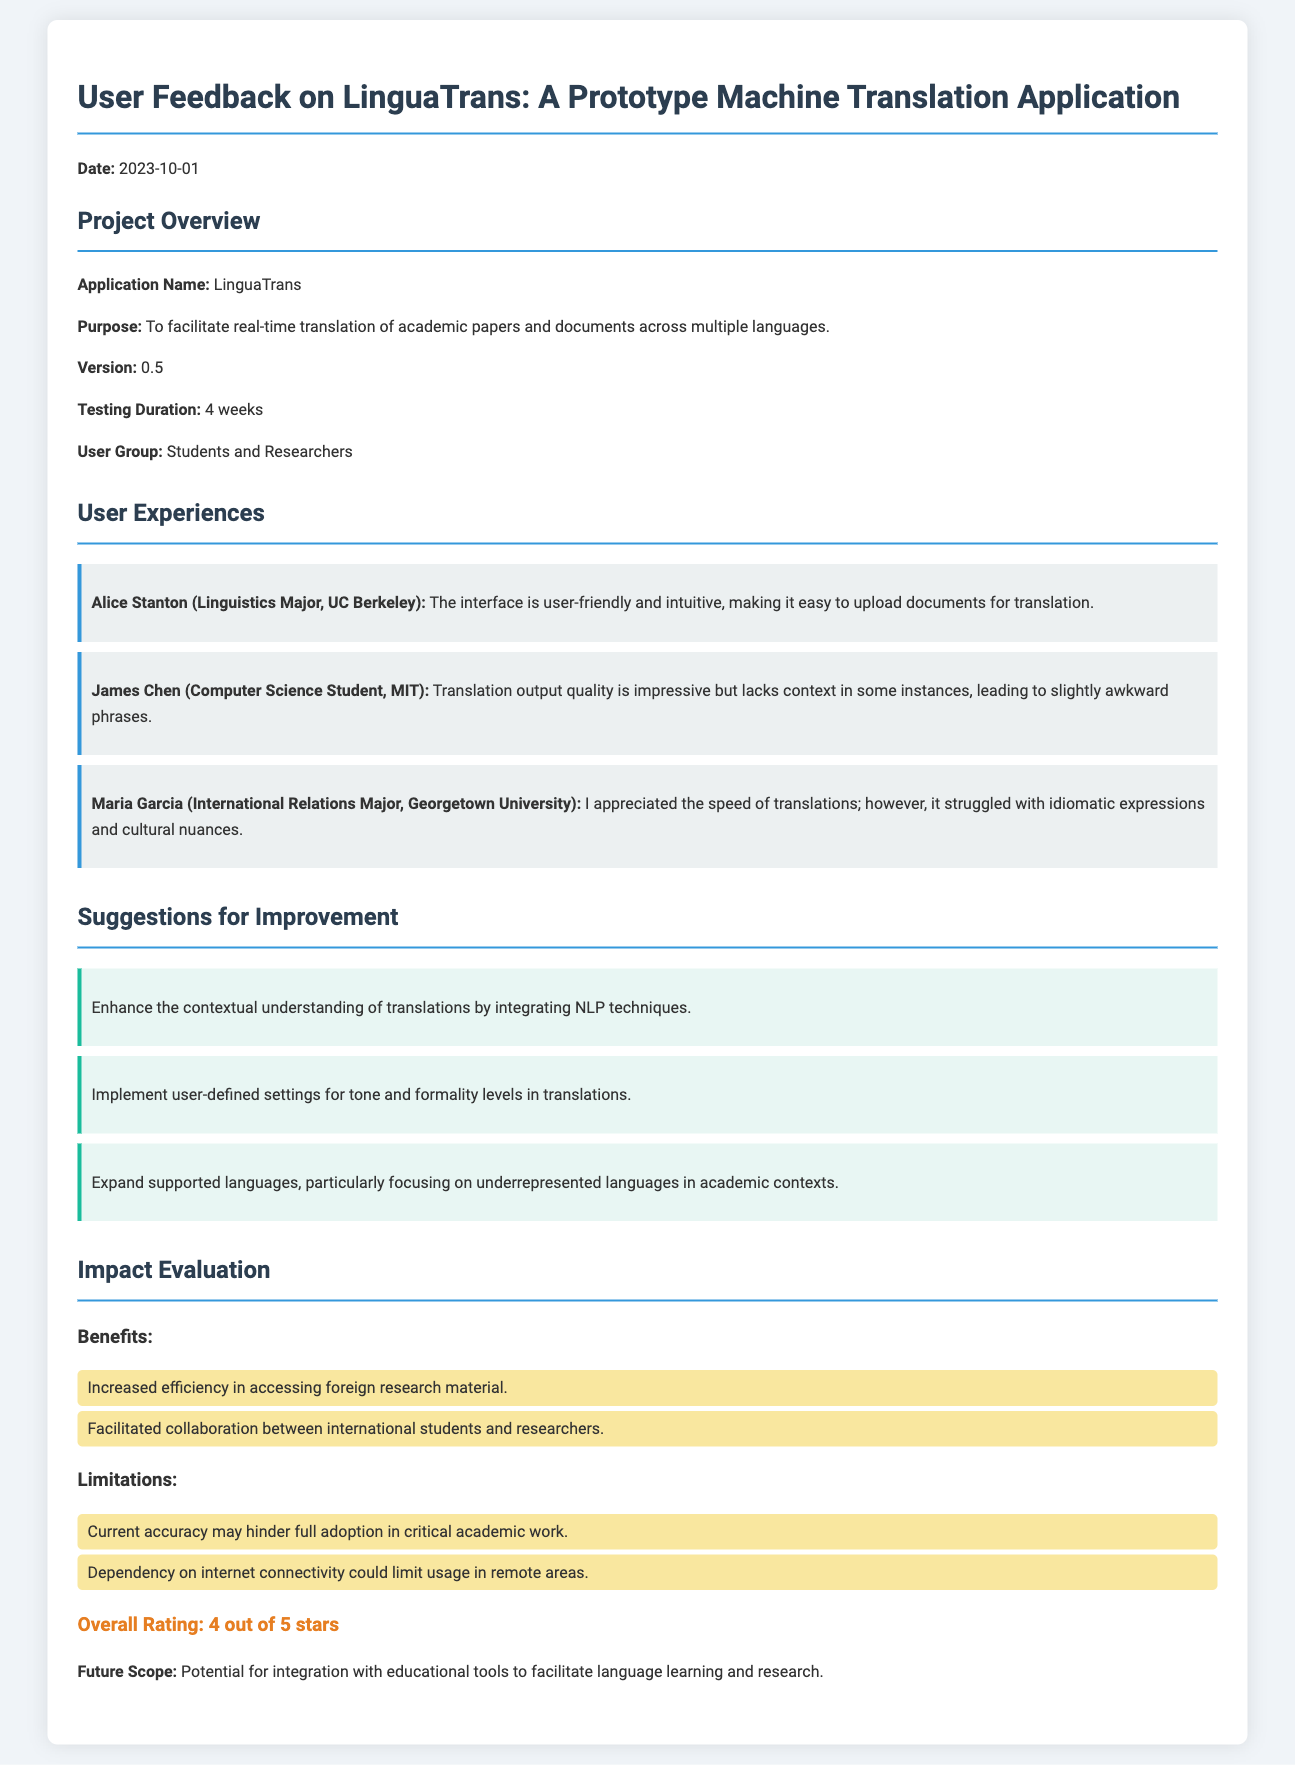What is the name of the application? The name of the application is mentioned in the Project Overview section.
Answer: LinguaTrans What is the testing duration for LinguaTrans? The testing duration is specified in the Project Overview section of the document.
Answer: 4 weeks Who is the user feedback from? The participants are listed in the User Experiences section, which details user backgrounds.
Answer: Students and Researchers What is a suggested improvement for LinguaTrans? Suggestions for improvement are provided in a specific section, highlighting user recommendations.
Answer: Enhance contextual understanding What is the overall rating given to the application? The overall rating is found in the Impact Evaluation section, summarizing user satisfaction.
Answer: 4 out of 5 stars What limitation is mentioned regarding current accuracy? Limitations are listed under Impact Evaluation, pertaining to the application’s performance.
Answer: Current accuracy may hinder full adoption What is a benefit of using LinguaTrans? Benefits are outlined in the Impact Evaluation section, showcasing positive impacts of the application.
Answer: Increased efficiency in accessing foreign research material What kind of students participated in the feedback? The document specifies the group of individuals providing feedback, found in the Project Overview.
Answer: Students and Researchers Which university does Alice Stanton attend? The information about Alice's affiliation is included in the User Experiences section.
Answer: UC Berkeley 